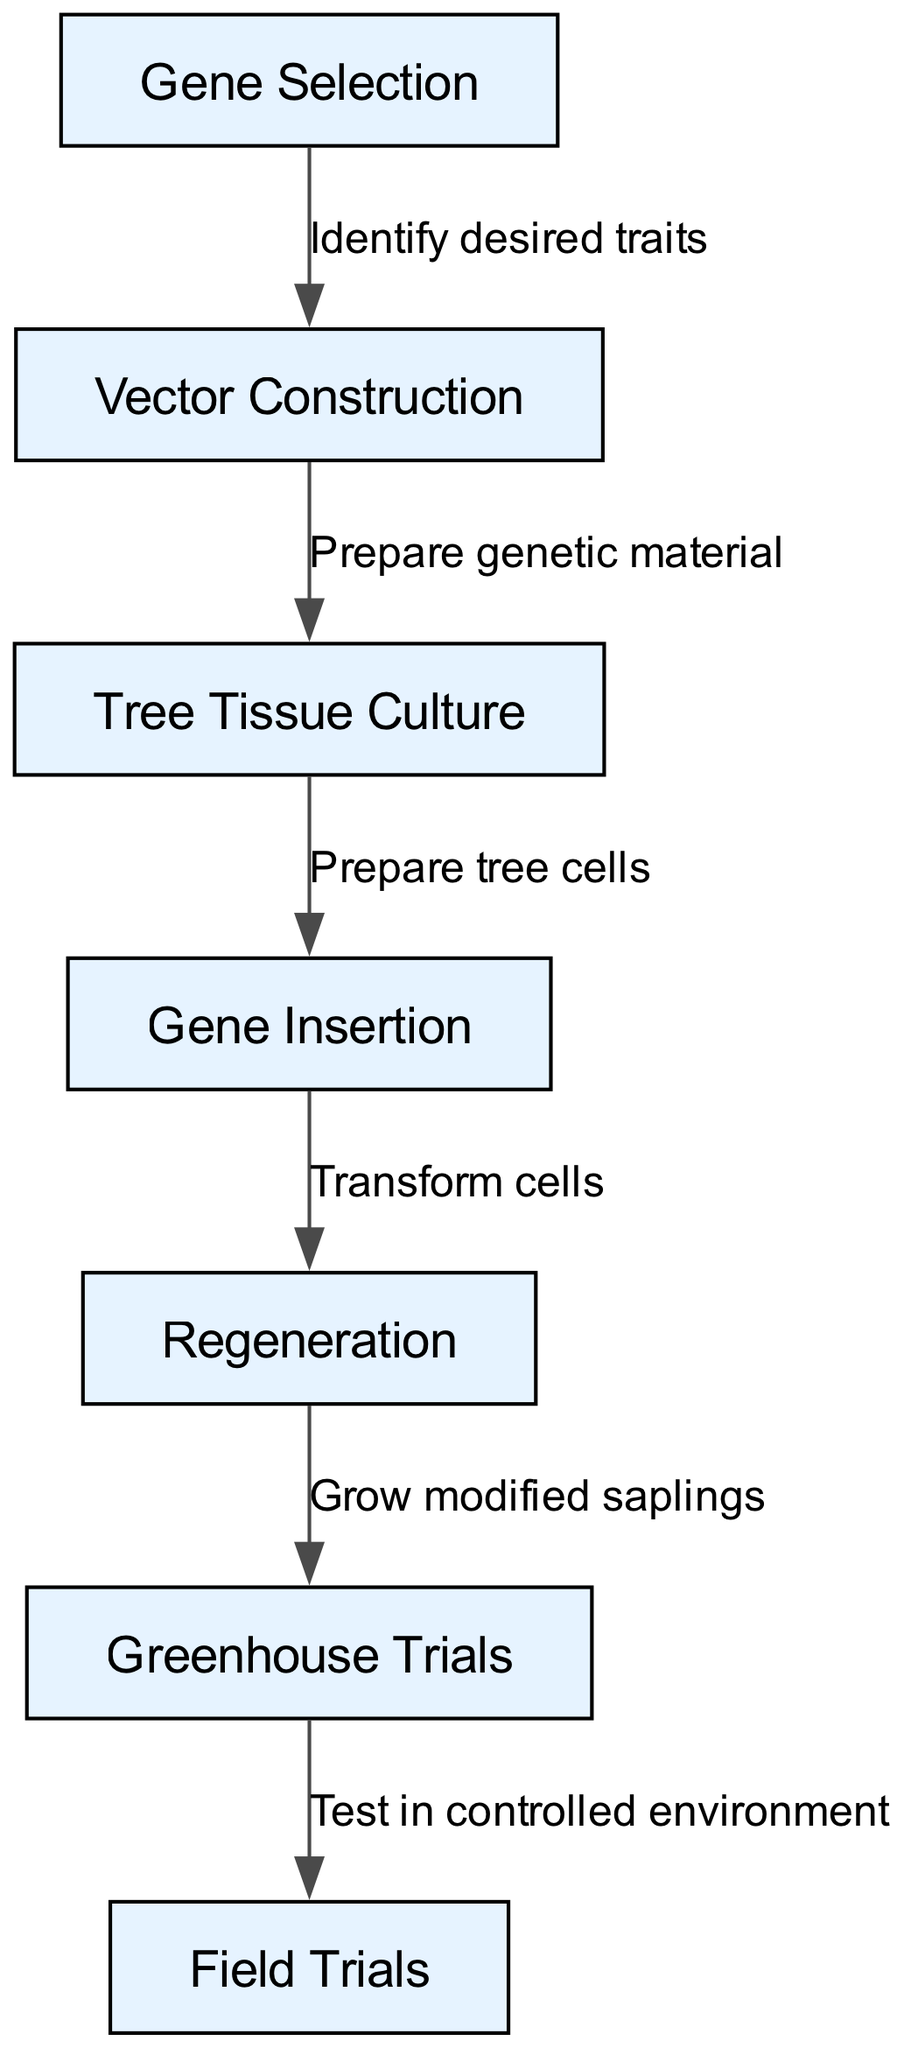What is the first step in the genetic modification process? The diagram indicates that the first step is "Gene Selection." This is the initial node, which does not have any preceding nodes, making it clear as the starting point of the flowchart.
Answer: Gene Selection How many nodes are depicted in the diagram? By counting the individual entries under "nodes," we find there are seven distinct nodes shown in the diagram that represent different stages in the genetic modification process.
Answer: 7 What is the relationship between "Gene Selection" and "Vector Construction"? The diagram illustrates that the flow from "Gene Selection" to "Vector Construction" is marked by the label "Identify desired traits." This indicates that the first step leads into the second step through this specific action.
Answer: Identify desired traits What process follows "Regeneration"? Looking at the flowchart, the step that directly follows "Regeneration" is the "Greenhouse Trials," indicating the next phase after the regeneration of modified plant cells.
Answer: Greenhouse Trials How many edges are there in total in the diagram? By examining the "edges" section of the diagram data, we can count the distinct pathways connecting the nodes, resulting in a total of six edges that describe the processes linking the various stages.
Answer: 6 What step tests the modified trees in a controlled environment? According to the flowchart, the "Greenhouse Trials" are conducted to test the modified trees in a controlled setting before they transition to the field trials. This step is crucial for initial assessment of the modified trees.
Answer: Greenhouse Trials Which step involves preparing the genetic material? The diagram shows that "Vector Construction" is the step where genetic material is prepared, following the selection of the desired genes and traits identified in the "Gene Selection" stage.
Answer: Vector Construction What is the last step in the genetic modification process? The final process depicted in the flowchart is "Field Trials." This step concludes the flow as it represents the ultimate evaluation of the genetically modified trees in a natural setting.
Answer: Field Trials 